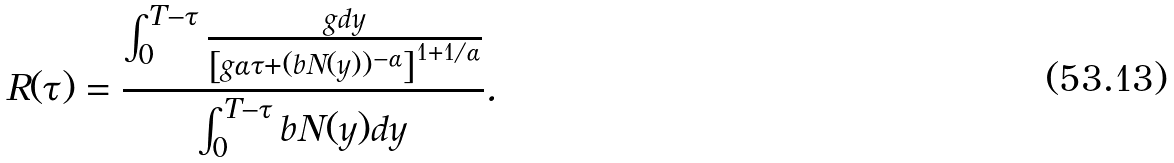<formula> <loc_0><loc_0><loc_500><loc_500>R ( \tau ) = \frac { \int _ { 0 } ^ { T - \tau } \frac { g d y } { \left [ g \alpha \tau + ( b N ( y ) ) ^ { - \alpha } \right ] ^ { 1 + 1 / \alpha } } } { \int _ { 0 } ^ { T - \tau } b N ( y ) d y } .</formula> 